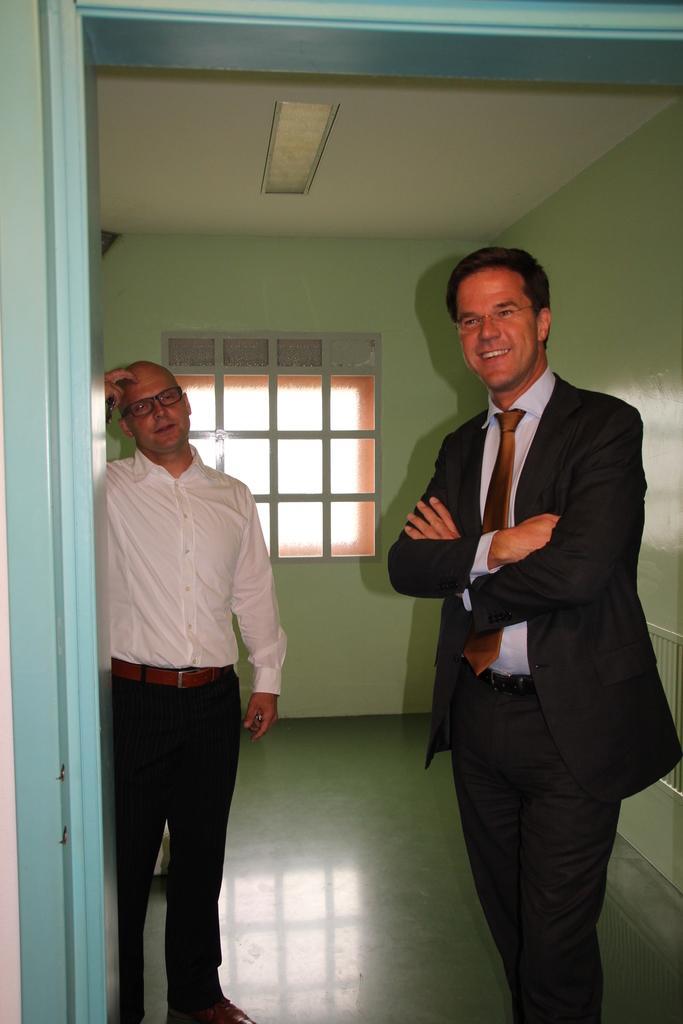Could you give a brief overview of what you see in this image? In this picture we can see two men standing a man on the right side is smiling, in the background there is a wall, we can see a window here, there is a light at the top of the picture. 